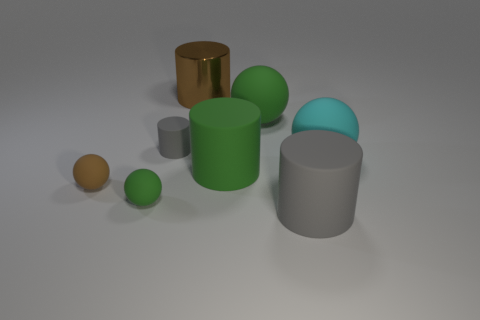What is the size of the shiny cylinder?
Make the answer very short. Large. There is a small matte ball that is left of the tiny green thing; is its color the same as the large thing that is left of the green matte cylinder?
Your answer should be very brief. Yes. How many other things are there of the same material as the brown cylinder?
Your answer should be compact. 0. Is there a small rubber block?
Your answer should be compact. No. Is the material of the gray object behind the big gray rubber thing the same as the large cyan sphere?
Your response must be concise. Yes. What is the material of the big green thing that is the same shape as the small gray thing?
Provide a short and direct response. Rubber. There is a large cylinder that is the same color as the small cylinder; what material is it?
Your answer should be very brief. Rubber. Is the number of big brown metallic objects less than the number of green balls?
Offer a very short reply. Yes. There is a big cylinder that is in front of the green rubber cylinder; is it the same color as the tiny matte cylinder?
Your response must be concise. Yes. What is the color of the tiny cylinder that is the same material as the large gray cylinder?
Your answer should be very brief. Gray. 